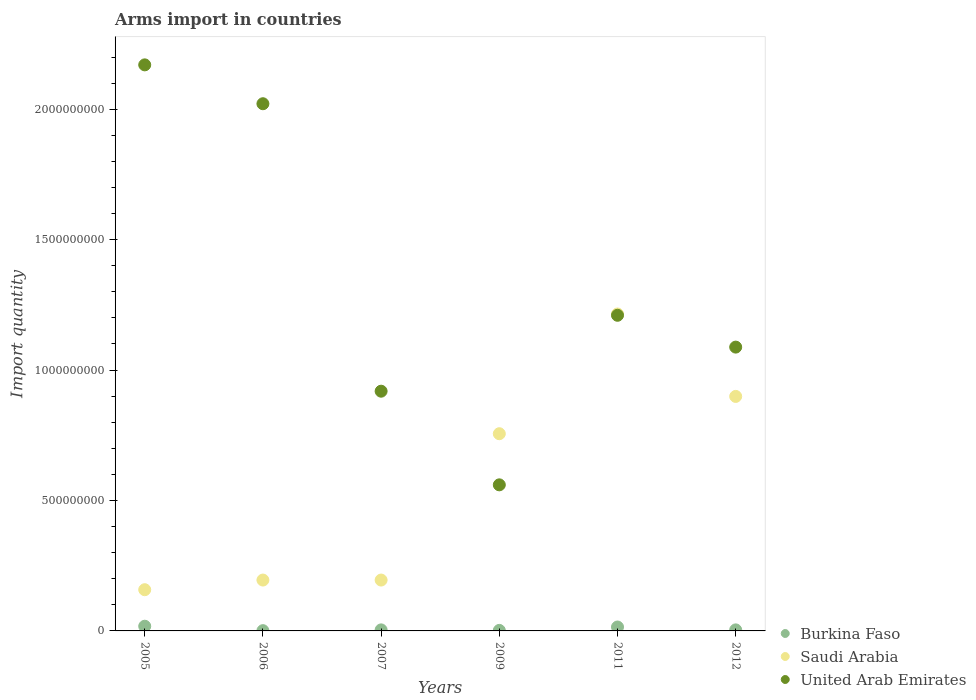How many different coloured dotlines are there?
Make the answer very short. 3. Is the number of dotlines equal to the number of legend labels?
Ensure brevity in your answer.  Yes. What is the total arms import in Burkina Faso in 2006?
Keep it short and to the point. 1.00e+06. Across all years, what is the maximum total arms import in Saudi Arabia?
Your answer should be compact. 1.22e+09. Across all years, what is the minimum total arms import in Saudi Arabia?
Make the answer very short. 1.58e+08. In which year was the total arms import in Saudi Arabia minimum?
Provide a succinct answer. 2005. What is the total total arms import in United Arab Emirates in the graph?
Provide a short and direct response. 7.97e+09. What is the difference between the total arms import in Burkina Faso in 2007 and that in 2011?
Your answer should be very brief. -1.10e+07. What is the difference between the total arms import in Burkina Faso in 2006 and the total arms import in Saudi Arabia in 2011?
Make the answer very short. -1.21e+09. What is the average total arms import in Saudi Arabia per year?
Provide a short and direct response. 5.70e+08. In the year 2009, what is the difference between the total arms import in Saudi Arabia and total arms import in United Arab Emirates?
Your response must be concise. 1.96e+08. What is the ratio of the total arms import in Burkina Faso in 2006 to that in 2009?
Provide a short and direct response. 0.5. Is the total arms import in Saudi Arabia in 2011 less than that in 2012?
Make the answer very short. No. What is the difference between the highest and the second highest total arms import in Burkina Faso?
Your response must be concise. 3.00e+06. What is the difference between the highest and the lowest total arms import in Saudi Arabia?
Provide a succinct answer. 1.06e+09. Is it the case that in every year, the sum of the total arms import in Saudi Arabia and total arms import in Burkina Faso  is greater than the total arms import in United Arab Emirates?
Your response must be concise. No. Does the total arms import in Burkina Faso monotonically increase over the years?
Provide a short and direct response. No. What is the difference between two consecutive major ticks on the Y-axis?
Provide a succinct answer. 5.00e+08. Where does the legend appear in the graph?
Offer a terse response. Bottom right. What is the title of the graph?
Provide a short and direct response. Arms import in countries. What is the label or title of the X-axis?
Offer a very short reply. Years. What is the label or title of the Y-axis?
Provide a succinct answer. Import quantity. What is the Import quantity in Burkina Faso in 2005?
Provide a short and direct response. 1.80e+07. What is the Import quantity of Saudi Arabia in 2005?
Make the answer very short. 1.58e+08. What is the Import quantity of United Arab Emirates in 2005?
Your answer should be compact. 2.17e+09. What is the Import quantity in Saudi Arabia in 2006?
Your response must be concise. 1.95e+08. What is the Import quantity in United Arab Emirates in 2006?
Give a very brief answer. 2.02e+09. What is the Import quantity of Burkina Faso in 2007?
Offer a terse response. 4.00e+06. What is the Import quantity of Saudi Arabia in 2007?
Ensure brevity in your answer.  1.95e+08. What is the Import quantity in United Arab Emirates in 2007?
Provide a short and direct response. 9.19e+08. What is the Import quantity in Saudi Arabia in 2009?
Ensure brevity in your answer.  7.56e+08. What is the Import quantity in United Arab Emirates in 2009?
Your answer should be compact. 5.60e+08. What is the Import quantity in Burkina Faso in 2011?
Offer a terse response. 1.50e+07. What is the Import quantity of Saudi Arabia in 2011?
Make the answer very short. 1.22e+09. What is the Import quantity of United Arab Emirates in 2011?
Your answer should be very brief. 1.21e+09. What is the Import quantity in Saudi Arabia in 2012?
Ensure brevity in your answer.  8.99e+08. What is the Import quantity in United Arab Emirates in 2012?
Ensure brevity in your answer.  1.09e+09. Across all years, what is the maximum Import quantity in Burkina Faso?
Provide a succinct answer. 1.80e+07. Across all years, what is the maximum Import quantity in Saudi Arabia?
Provide a short and direct response. 1.22e+09. Across all years, what is the maximum Import quantity in United Arab Emirates?
Give a very brief answer. 2.17e+09. Across all years, what is the minimum Import quantity of Burkina Faso?
Offer a very short reply. 1.00e+06. Across all years, what is the minimum Import quantity in Saudi Arabia?
Provide a short and direct response. 1.58e+08. Across all years, what is the minimum Import quantity in United Arab Emirates?
Offer a terse response. 5.60e+08. What is the total Import quantity of Burkina Faso in the graph?
Provide a succinct answer. 4.40e+07. What is the total Import quantity of Saudi Arabia in the graph?
Keep it short and to the point. 3.42e+09. What is the total Import quantity of United Arab Emirates in the graph?
Your response must be concise. 7.97e+09. What is the difference between the Import quantity in Burkina Faso in 2005 and that in 2006?
Offer a very short reply. 1.70e+07. What is the difference between the Import quantity of Saudi Arabia in 2005 and that in 2006?
Offer a terse response. -3.70e+07. What is the difference between the Import quantity in United Arab Emirates in 2005 and that in 2006?
Your response must be concise. 1.49e+08. What is the difference between the Import quantity in Burkina Faso in 2005 and that in 2007?
Offer a terse response. 1.40e+07. What is the difference between the Import quantity in Saudi Arabia in 2005 and that in 2007?
Give a very brief answer. -3.70e+07. What is the difference between the Import quantity of United Arab Emirates in 2005 and that in 2007?
Your answer should be compact. 1.25e+09. What is the difference between the Import quantity of Burkina Faso in 2005 and that in 2009?
Offer a terse response. 1.60e+07. What is the difference between the Import quantity of Saudi Arabia in 2005 and that in 2009?
Keep it short and to the point. -5.98e+08. What is the difference between the Import quantity in United Arab Emirates in 2005 and that in 2009?
Ensure brevity in your answer.  1.61e+09. What is the difference between the Import quantity in Burkina Faso in 2005 and that in 2011?
Give a very brief answer. 3.00e+06. What is the difference between the Import quantity in Saudi Arabia in 2005 and that in 2011?
Make the answer very short. -1.06e+09. What is the difference between the Import quantity in United Arab Emirates in 2005 and that in 2011?
Provide a succinct answer. 9.60e+08. What is the difference between the Import quantity of Burkina Faso in 2005 and that in 2012?
Offer a terse response. 1.40e+07. What is the difference between the Import quantity of Saudi Arabia in 2005 and that in 2012?
Offer a terse response. -7.41e+08. What is the difference between the Import quantity of United Arab Emirates in 2005 and that in 2012?
Offer a very short reply. 1.08e+09. What is the difference between the Import quantity of Burkina Faso in 2006 and that in 2007?
Offer a terse response. -3.00e+06. What is the difference between the Import quantity in Saudi Arabia in 2006 and that in 2007?
Your answer should be very brief. 0. What is the difference between the Import quantity in United Arab Emirates in 2006 and that in 2007?
Your answer should be compact. 1.10e+09. What is the difference between the Import quantity in Burkina Faso in 2006 and that in 2009?
Provide a succinct answer. -1.00e+06. What is the difference between the Import quantity in Saudi Arabia in 2006 and that in 2009?
Offer a terse response. -5.61e+08. What is the difference between the Import quantity in United Arab Emirates in 2006 and that in 2009?
Give a very brief answer. 1.46e+09. What is the difference between the Import quantity of Burkina Faso in 2006 and that in 2011?
Give a very brief answer. -1.40e+07. What is the difference between the Import quantity in Saudi Arabia in 2006 and that in 2011?
Offer a terse response. -1.02e+09. What is the difference between the Import quantity of United Arab Emirates in 2006 and that in 2011?
Provide a short and direct response. 8.11e+08. What is the difference between the Import quantity of Burkina Faso in 2006 and that in 2012?
Make the answer very short. -3.00e+06. What is the difference between the Import quantity of Saudi Arabia in 2006 and that in 2012?
Offer a very short reply. -7.04e+08. What is the difference between the Import quantity of United Arab Emirates in 2006 and that in 2012?
Offer a very short reply. 9.33e+08. What is the difference between the Import quantity in Saudi Arabia in 2007 and that in 2009?
Your answer should be compact. -5.61e+08. What is the difference between the Import quantity of United Arab Emirates in 2007 and that in 2009?
Ensure brevity in your answer.  3.59e+08. What is the difference between the Import quantity in Burkina Faso in 2007 and that in 2011?
Your answer should be compact. -1.10e+07. What is the difference between the Import quantity in Saudi Arabia in 2007 and that in 2011?
Give a very brief answer. -1.02e+09. What is the difference between the Import quantity in United Arab Emirates in 2007 and that in 2011?
Your answer should be compact. -2.91e+08. What is the difference between the Import quantity in Saudi Arabia in 2007 and that in 2012?
Provide a short and direct response. -7.04e+08. What is the difference between the Import quantity in United Arab Emirates in 2007 and that in 2012?
Keep it short and to the point. -1.69e+08. What is the difference between the Import quantity in Burkina Faso in 2009 and that in 2011?
Offer a terse response. -1.30e+07. What is the difference between the Import quantity in Saudi Arabia in 2009 and that in 2011?
Your answer should be compact. -4.59e+08. What is the difference between the Import quantity in United Arab Emirates in 2009 and that in 2011?
Your response must be concise. -6.50e+08. What is the difference between the Import quantity of Burkina Faso in 2009 and that in 2012?
Your response must be concise. -2.00e+06. What is the difference between the Import quantity in Saudi Arabia in 2009 and that in 2012?
Give a very brief answer. -1.43e+08. What is the difference between the Import quantity in United Arab Emirates in 2009 and that in 2012?
Ensure brevity in your answer.  -5.28e+08. What is the difference between the Import quantity in Burkina Faso in 2011 and that in 2012?
Ensure brevity in your answer.  1.10e+07. What is the difference between the Import quantity of Saudi Arabia in 2011 and that in 2012?
Offer a very short reply. 3.16e+08. What is the difference between the Import quantity in United Arab Emirates in 2011 and that in 2012?
Make the answer very short. 1.22e+08. What is the difference between the Import quantity in Burkina Faso in 2005 and the Import quantity in Saudi Arabia in 2006?
Provide a short and direct response. -1.77e+08. What is the difference between the Import quantity in Burkina Faso in 2005 and the Import quantity in United Arab Emirates in 2006?
Offer a very short reply. -2.00e+09. What is the difference between the Import quantity of Saudi Arabia in 2005 and the Import quantity of United Arab Emirates in 2006?
Your answer should be compact. -1.86e+09. What is the difference between the Import quantity of Burkina Faso in 2005 and the Import quantity of Saudi Arabia in 2007?
Your response must be concise. -1.77e+08. What is the difference between the Import quantity of Burkina Faso in 2005 and the Import quantity of United Arab Emirates in 2007?
Provide a short and direct response. -9.01e+08. What is the difference between the Import quantity in Saudi Arabia in 2005 and the Import quantity in United Arab Emirates in 2007?
Make the answer very short. -7.61e+08. What is the difference between the Import quantity of Burkina Faso in 2005 and the Import quantity of Saudi Arabia in 2009?
Offer a very short reply. -7.38e+08. What is the difference between the Import quantity of Burkina Faso in 2005 and the Import quantity of United Arab Emirates in 2009?
Your response must be concise. -5.42e+08. What is the difference between the Import quantity in Saudi Arabia in 2005 and the Import quantity in United Arab Emirates in 2009?
Provide a short and direct response. -4.02e+08. What is the difference between the Import quantity of Burkina Faso in 2005 and the Import quantity of Saudi Arabia in 2011?
Offer a very short reply. -1.20e+09. What is the difference between the Import quantity of Burkina Faso in 2005 and the Import quantity of United Arab Emirates in 2011?
Keep it short and to the point. -1.19e+09. What is the difference between the Import quantity of Saudi Arabia in 2005 and the Import quantity of United Arab Emirates in 2011?
Your answer should be compact. -1.05e+09. What is the difference between the Import quantity of Burkina Faso in 2005 and the Import quantity of Saudi Arabia in 2012?
Give a very brief answer. -8.81e+08. What is the difference between the Import quantity in Burkina Faso in 2005 and the Import quantity in United Arab Emirates in 2012?
Your answer should be very brief. -1.07e+09. What is the difference between the Import quantity in Saudi Arabia in 2005 and the Import quantity in United Arab Emirates in 2012?
Give a very brief answer. -9.30e+08. What is the difference between the Import quantity of Burkina Faso in 2006 and the Import quantity of Saudi Arabia in 2007?
Give a very brief answer. -1.94e+08. What is the difference between the Import quantity in Burkina Faso in 2006 and the Import quantity in United Arab Emirates in 2007?
Ensure brevity in your answer.  -9.18e+08. What is the difference between the Import quantity of Saudi Arabia in 2006 and the Import quantity of United Arab Emirates in 2007?
Provide a succinct answer. -7.24e+08. What is the difference between the Import quantity in Burkina Faso in 2006 and the Import quantity in Saudi Arabia in 2009?
Make the answer very short. -7.55e+08. What is the difference between the Import quantity of Burkina Faso in 2006 and the Import quantity of United Arab Emirates in 2009?
Keep it short and to the point. -5.59e+08. What is the difference between the Import quantity of Saudi Arabia in 2006 and the Import quantity of United Arab Emirates in 2009?
Keep it short and to the point. -3.65e+08. What is the difference between the Import quantity in Burkina Faso in 2006 and the Import quantity in Saudi Arabia in 2011?
Ensure brevity in your answer.  -1.21e+09. What is the difference between the Import quantity of Burkina Faso in 2006 and the Import quantity of United Arab Emirates in 2011?
Provide a short and direct response. -1.21e+09. What is the difference between the Import quantity of Saudi Arabia in 2006 and the Import quantity of United Arab Emirates in 2011?
Offer a very short reply. -1.02e+09. What is the difference between the Import quantity of Burkina Faso in 2006 and the Import quantity of Saudi Arabia in 2012?
Ensure brevity in your answer.  -8.98e+08. What is the difference between the Import quantity in Burkina Faso in 2006 and the Import quantity in United Arab Emirates in 2012?
Provide a short and direct response. -1.09e+09. What is the difference between the Import quantity of Saudi Arabia in 2006 and the Import quantity of United Arab Emirates in 2012?
Your response must be concise. -8.93e+08. What is the difference between the Import quantity in Burkina Faso in 2007 and the Import quantity in Saudi Arabia in 2009?
Offer a terse response. -7.52e+08. What is the difference between the Import quantity in Burkina Faso in 2007 and the Import quantity in United Arab Emirates in 2009?
Make the answer very short. -5.56e+08. What is the difference between the Import quantity in Saudi Arabia in 2007 and the Import quantity in United Arab Emirates in 2009?
Offer a terse response. -3.65e+08. What is the difference between the Import quantity in Burkina Faso in 2007 and the Import quantity in Saudi Arabia in 2011?
Offer a terse response. -1.21e+09. What is the difference between the Import quantity in Burkina Faso in 2007 and the Import quantity in United Arab Emirates in 2011?
Give a very brief answer. -1.21e+09. What is the difference between the Import quantity of Saudi Arabia in 2007 and the Import quantity of United Arab Emirates in 2011?
Your response must be concise. -1.02e+09. What is the difference between the Import quantity of Burkina Faso in 2007 and the Import quantity of Saudi Arabia in 2012?
Keep it short and to the point. -8.95e+08. What is the difference between the Import quantity of Burkina Faso in 2007 and the Import quantity of United Arab Emirates in 2012?
Ensure brevity in your answer.  -1.08e+09. What is the difference between the Import quantity of Saudi Arabia in 2007 and the Import quantity of United Arab Emirates in 2012?
Make the answer very short. -8.93e+08. What is the difference between the Import quantity in Burkina Faso in 2009 and the Import quantity in Saudi Arabia in 2011?
Keep it short and to the point. -1.21e+09. What is the difference between the Import quantity of Burkina Faso in 2009 and the Import quantity of United Arab Emirates in 2011?
Offer a terse response. -1.21e+09. What is the difference between the Import quantity of Saudi Arabia in 2009 and the Import quantity of United Arab Emirates in 2011?
Make the answer very short. -4.54e+08. What is the difference between the Import quantity in Burkina Faso in 2009 and the Import quantity in Saudi Arabia in 2012?
Make the answer very short. -8.97e+08. What is the difference between the Import quantity in Burkina Faso in 2009 and the Import quantity in United Arab Emirates in 2012?
Your answer should be very brief. -1.09e+09. What is the difference between the Import quantity of Saudi Arabia in 2009 and the Import quantity of United Arab Emirates in 2012?
Give a very brief answer. -3.32e+08. What is the difference between the Import quantity of Burkina Faso in 2011 and the Import quantity of Saudi Arabia in 2012?
Give a very brief answer. -8.84e+08. What is the difference between the Import quantity of Burkina Faso in 2011 and the Import quantity of United Arab Emirates in 2012?
Your answer should be very brief. -1.07e+09. What is the difference between the Import quantity of Saudi Arabia in 2011 and the Import quantity of United Arab Emirates in 2012?
Offer a terse response. 1.27e+08. What is the average Import quantity of Burkina Faso per year?
Provide a short and direct response. 7.33e+06. What is the average Import quantity in Saudi Arabia per year?
Your answer should be compact. 5.70e+08. What is the average Import quantity of United Arab Emirates per year?
Your answer should be compact. 1.33e+09. In the year 2005, what is the difference between the Import quantity of Burkina Faso and Import quantity of Saudi Arabia?
Provide a succinct answer. -1.40e+08. In the year 2005, what is the difference between the Import quantity in Burkina Faso and Import quantity in United Arab Emirates?
Your response must be concise. -2.15e+09. In the year 2005, what is the difference between the Import quantity of Saudi Arabia and Import quantity of United Arab Emirates?
Your answer should be compact. -2.01e+09. In the year 2006, what is the difference between the Import quantity in Burkina Faso and Import quantity in Saudi Arabia?
Make the answer very short. -1.94e+08. In the year 2006, what is the difference between the Import quantity in Burkina Faso and Import quantity in United Arab Emirates?
Ensure brevity in your answer.  -2.02e+09. In the year 2006, what is the difference between the Import quantity of Saudi Arabia and Import quantity of United Arab Emirates?
Ensure brevity in your answer.  -1.83e+09. In the year 2007, what is the difference between the Import quantity of Burkina Faso and Import quantity of Saudi Arabia?
Provide a succinct answer. -1.91e+08. In the year 2007, what is the difference between the Import quantity in Burkina Faso and Import quantity in United Arab Emirates?
Offer a very short reply. -9.15e+08. In the year 2007, what is the difference between the Import quantity in Saudi Arabia and Import quantity in United Arab Emirates?
Make the answer very short. -7.24e+08. In the year 2009, what is the difference between the Import quantity of Burkina Faso and Import quantity of Saudi Arabia?
Offer a terse response. -7.54e+08. In the year 2009, what is the difference between the Import quantity in Burkina Faso and Import quantity in United Arab Emirates?
Provide a short and direct response. -5.58e+08. In the year 2009, what is the difference between the Import quantity in Saudi Arabia and Import quantity in United Arab Emirates?
Keep it short and to the point. 1.96e+08. In the year 2011, what is the difference between the Import quantity of Burkina Faso and Import quantity of Saudi Arabia?
Provide a succinct answer. -1.20e+09. In the year 2011, what is the difference between the Import quantity of Burkina Faso and Import quantity of United Arab Emirates?
Provide a short and direct response. -1.20e+09. In the year 2011, what is the difference between the Import quantity of Saudi Arabia and Import quantity of United Arab Emirates?
Provide a succinct answer. 5.00e+06. In the year 2012, what is the difference between the Import quantity in Burkina Faso and Import quantity in Saudi Arabia?
Your response must be concise. -8.95e+08. In the year 2012, what is the difference between the Import quantity in Burkina Faso and Import quantity in United Arab Emirates?
Offer a terse response. -1.08e+09. In the year 2012, what is the difference between the Import quantity of Saudi Arabia and Import quantity of United Arab Emirates?
Your response must be concise. -1.89e+08. What is the ratio of the Import quantity of Saudi Arabia in 2005 to that in 2006?
Give a very brief answer. 0.81. What is the ratio of the Import quantity in United Arab Emirates in 2005 to that in 2006?
Make the answer very short. 1.07. What is the ratio of the Import quantity of Burkina Faso in 2005 to that in 2007?
Give a very brief answer. 4.5. What is the ratio of the Import quantity in Saudi Arabia in 2005 to that in 2007?
Ensure brevity in your answer.  0.81. What is the ratio of the Import quantity in United Arab Emirates in 2005 to that in 2007?
Ensure brevity in your answer.  2.36. What is the ratio of the Import quantity of Burkina Faso in 2005 to that in 2009?
Keep it short and to the point. 9. What is the ratio of the Import quantity of Saudi Arabia in 2005 to that in 2009?
Give a very brief answer. 0.21. What is the ratio of the Import quantity in United Arab Emirates in 2005 to that in 2009?
Your answer should be compact. 3.88. What is the ratio of the Import quantity of Burkina Faso in 2005 to that in 2011?
Offer a very short reply. 1.2. What is the ratio of the Import quantity of Saudi Arabia in 2005 to that in 2011?
Provide a succinct answer. 0.13. What is the ratio of the Import quantity in United Arab Emirates in 2005 to that in 2011?
Your answer should be compact. 1.79. What is the ratio of the Import quantity of Saudi Arabia in 2005 to that in 2012?
Provide a short and direct response. 0.18. What is the ratio of the Import quantity in United Arab Emirates in 2005 to that in 2012?
Your answer should be compact. 1.99. What is the ratio of the Import quantity of Saudi Arabia in 2006 to that in 2007?
Offer a very short reply. 1. What is the ratio of the Import quantity in United Arab Emirates in 2006 to that in 2007?
Make the answer very short. 2.2. What is the ratio of the Import quantity of Burkina Faso in 2006 to that in 2009?
Your answer should be very brief. 0.5. What is the ratio of the Import quantity of Saudi Arabia in 2006 to that in 2009?
Your answer should be very brief. 0.26. What is the ratio of the Import quantity in United Arab Emirates in 2006 to that in 2009?
Your answer should be compact. 3.61. What is the ratio of the Import quantity of Burkina Faso in 2006 to that in 2011?
Ensure brevity in your answer.  0.07. What is the ratio of the Import quantity of Saudi Arabia in 2006 to that in 2011?
Offer a terse response. 0.16. What is the ratio of the Import quantity of United Arab Emirates in 2006 to that in 2011?
Ensure brevity in your answer.  1.67. What is the ratio of the Import quantity of Burkina Faso in 2006 to that in 2012?
Keep it short and to the point. 0.25. What is the ratio of the Import quantity of Saudi Arabia in 2006 to that in 2012?
Ensure brevity in your answer.  0.22. What is the ratio of the Import quantity of United Arab Emirates in 2006 to that in 2012?
Offer a terse response. 1.86. What is the ratio of the Import quantity of Saudi Arabia in 2007 to that in 2009?
Offer a terse response. 0.26. What is the ratio of the Import quantity of United Arab Emirates in 2007 to that in 2009?
Offer a terse response. 1.64. What is the ratio of the Import quantity in Burkina Faso in 2007 to that in 2011?
Provide a succinct answer. 0.27. What is the ratio of the Import quantity in Saudi Arabia in 2007 to that in 2011?
Keep it short and to the point. 0.16. What is the ratio of the Import quantity of United Arab Emirates in 2007 to that in 2011?
Offer a very short reply. 0.76. What is the ratio of the Import quantity in Burkina Faso in 2007 to that in 2012?
Give a very brief answer. 1. What is the ratio of the Import quantity in Saudi Arabia in 2007 to that in 2012?
Your answer should be compact. 0.22. What is the ratio of the Import quantity of United Arab Emirates in 2007 to that in 2012?
Provide a succinct answer. 0.84. What is the ratio of the Import quantity in Burkina Faso in 2009 to that in 2011?
Your response must be concise. 0.13. What is the ratio of the Import quantity in Saudi Arabia in 2009 to that in 2011?
Make the answer very short. 0.62. What is the ratio of the Import quantity in United Arab Emirates in 2009 to that in 2011?
Make the answer very short. 0.46. What is the ratio of the Import quantity of Burkina Faso in 2009 to that in 2012?
Ensure brevity in your answer.  0.5. What is the ratio of the Import quantity of Saudi Arabia in 2009 to that in 2012?
Ensure brevity in your answer.  0.84. What is the ratio of the Import quantity in United Arab Emirates in 2009 to that in 2012?
Offer a very short reply. 0.51. What is the ratio of the Import quantity of Burkina Faso in 2011 to that in 2012?
Offer a terse response. 3.75. What is the ratio of the Import quantity in Saudi Arabia in 2011 to that in 2012?
Your answer should be compact. 1.35. What is the ratio of the Import quantity in United Arab Emirates in 2011 to that in 2012?
Ensure brevity in your answer.  1.11. What is the difference between the highest and the second highest Import quantity in Burkina Faso?
Ensure brevity in your answer.  3.00e+06. What is the difference between the highest and the second highest Import quantity of Saudi Arabia?
Provide a short and direct response. 3.16e+08. What is the difference between the highest and the second highest Import quantity of United Arab Emirates?
Ensure brevity in your answer.  1.49e+08. What is the difference between the highest and the lowest Import quantity in Burkina Faso?
Your answer should be compact. 1.70e+07. What is the difference between the highest and the lowest Import quantity in Saudi Arabia?
Make the answer very short. 1.06e+09. What is the difference between the highest and the lowest Import quantity of United Arab Emirates?
Offer a terse response. 1.61e+09. 